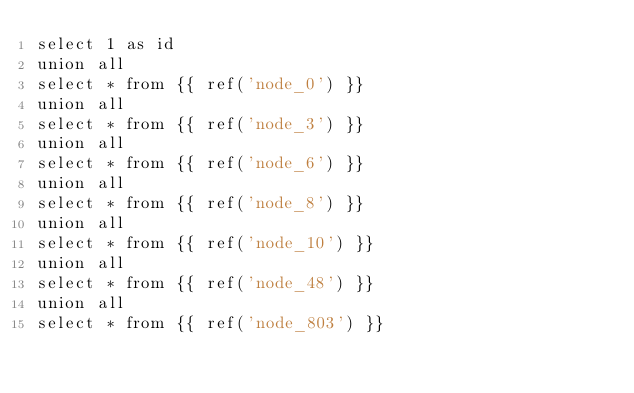Convert code to text. <code><loc_0><loc_0><loc_500><loc_500><_SQL_>select 1 as id
union all
select * from {{ ref('node_0') }}
union all
select * from {{ ref('node_3') }}
union all
select * from {{ ref('node_6') }}
union all
select * from {{ ref('node_8') }}
union all
select * from {{ ref('node_10') }}
union all
select * from {{ ref('node_48') }}
union all
select * from {{ ref('node_803') }}
</code> 